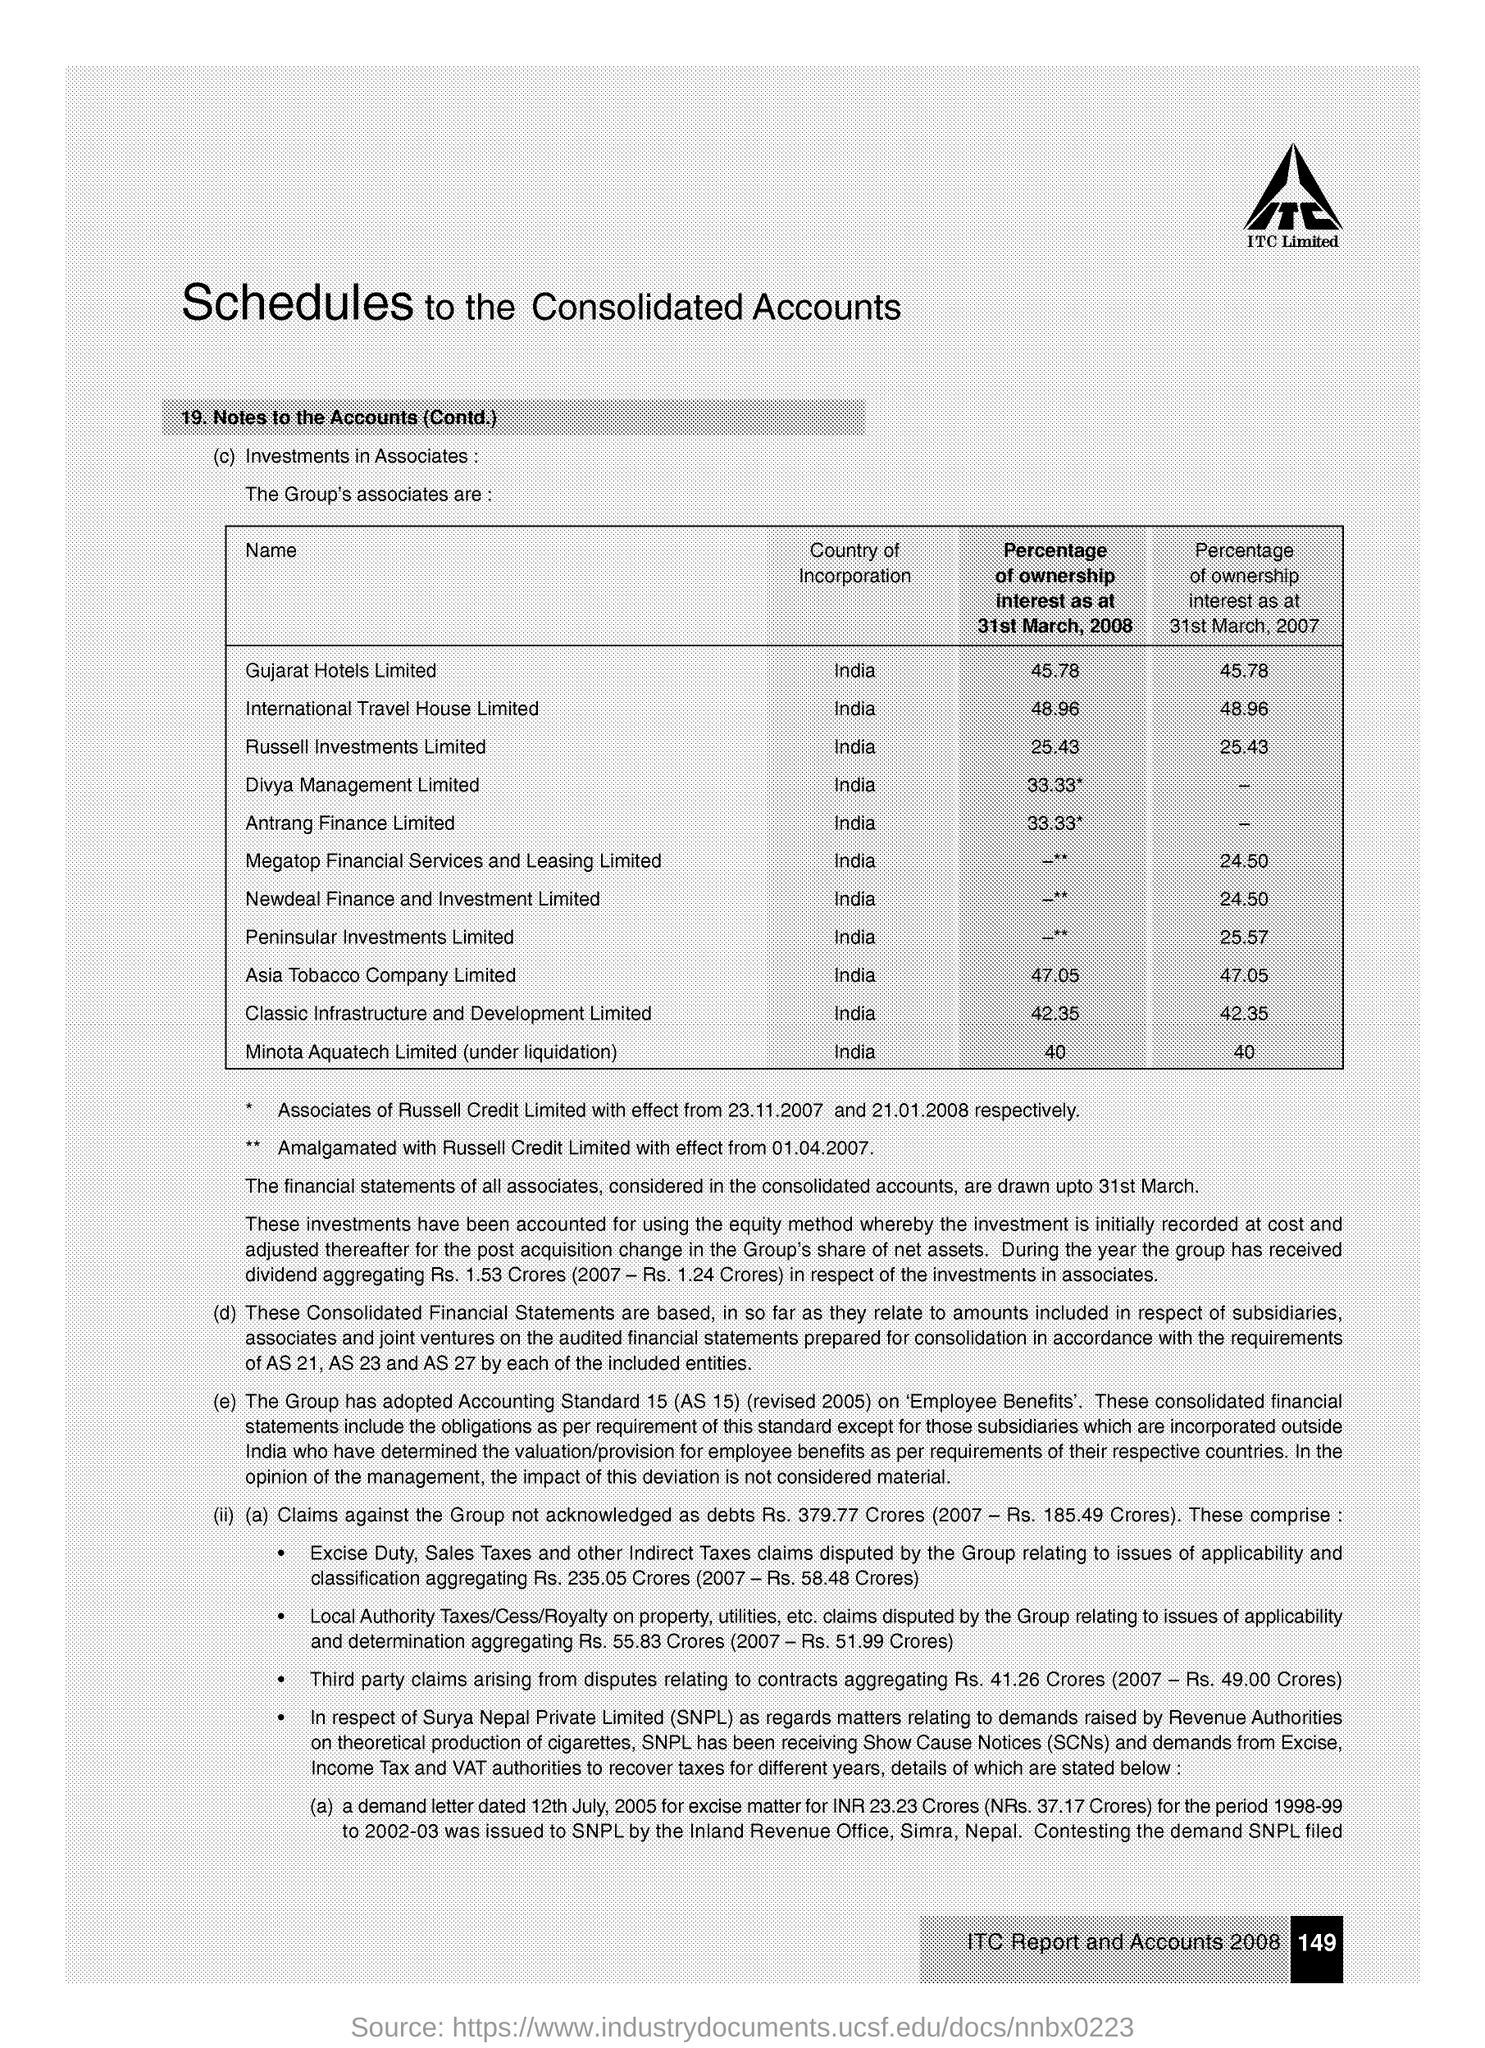What is the main title of this document?
Your response must be concise. Schedules to the Consolidated Accounts. Which company is mentioned in the header of the document?
Your response must be concise. ITC Limited. What is the Percentage of ownership interest as at 31st March, 2008  for Gujarat Hotels Limited?
Keep it short and to the point. 45.78. Which is the Country of Incorporation of  Russell Investments Limited?
Provide a short and direct response. India. What is the Percentage of ownership interest as at 31st March, 2008  for Asia Tobacco Company Limited?
Offer a terse response. 47.05. Which is the Country of Incorporation of  Antrang Finance Limited?
Keep it short and to the point. India. What is the Percentage of ownership interest as at 31st March, 2007  for Peninsular Investments Limited?
Your answer should be compact. 25.57. What is the page no mentioned in this document?
Ensure brevity in your answer.  149. 